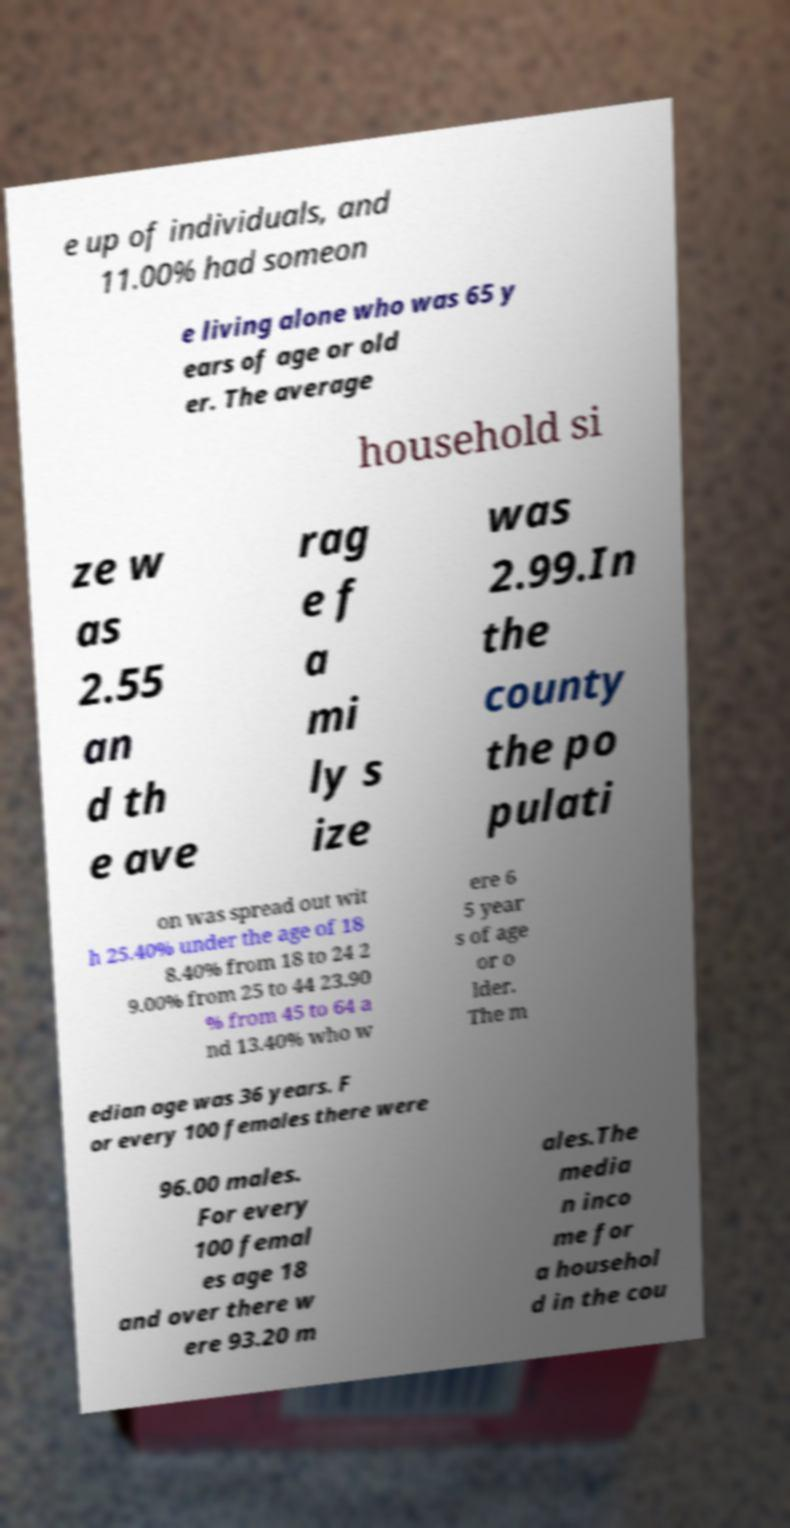Please identify and transcribe the text found in this image. e up of individuals, and 11.00% had someon e living alone who was 65 y ears of age or old er. The average household si ze w as 2.55 an d th e ave rag e f a mi ly s ize was 2.99.In the county the po pulati on was spread out wit h 25.40% under the age of 18 8.40% from 18 to 24 2 9.00% from 25 to 44 23.90 % from 45 to 64 a nd 13.40% who w ere 6 5 year s of age or o lder. The m edian age was 36 years. F or every 100 females there were 96.00 males. For every 100 femal es age 18 and over there w ere 93.20 m ales.The media n inco me for a househol d in the cou 